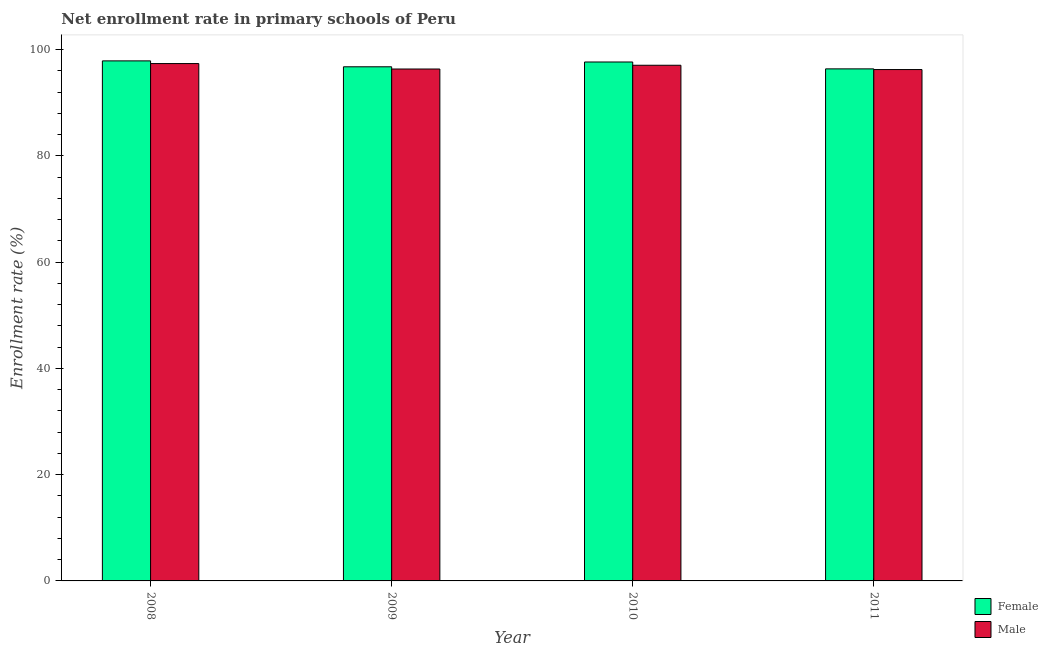Are the number of bars on each tick of the X-axis equal?
Ensure brevity in your answer.  Yes. How many bars are there on the 2nd tick from the left?
Offer a very short reply. 2. How many bars are there on the 1st tick from the right?
Provide a short and direct response. 2. In how many cases, is the number of bars for a given year not equal to the number of legend labels?
Your answer should be compact. 0. What is the enrollment rate of female students in 2009?
Your answer should be very brief. 96.78. Across all years, what is the maximum enrollment rate of male students?
Offer a very short reply. 97.39. Across all years, what is the minimum enrollment rate of female students?
Your answer should be very brief. 96.39. In which year was the enrollment rate of female students minimum?
Your answer should be very brief. 2011. What is the total enrollment rate of male students in the graph?
Your response must be concise. 387.09. What is the difference between the enrollment rate of female students in 2008 and that in 2011?
Your answer should be compact. 1.5. What is the difference between the enrollment rate of male students in 2008 and the enrollment rate of female students in 2010?
Offer a very short reply. 0.32. What is the average enrollment rate of female students per year?
Provide a short and direct response. 97.19. In the year 2009, what is the difference between the enrollment rate of male students and enrollment rate of female students?
Give a very brief answer. 0. What is the ratio of the enrollment rate of female students in 2008 to that in 2010?
Provide a short and direct response. 1. Is the difference between the enrollment rate of female students in 2010 and 2011 greater than the difference between the enrollment rate of male students in 2010 and 2011?
Keep it short and to the point. No. What is the difference between the highest and the second highest enrollment rate of female students?
Your answer should be compact. 0.21. What is the difference between the highest and the lowest enrollment rate of female students?
Offer a very short reply. 1.5. How many bars are there?
Your response must be concise. 8. Are all the bars in the graph horizontal?
Provide a short and direct response. No. Does the graph contain any zero values?
Provide a succinct answer. No. Where does the legend appear in the graph?
Keep it short and to the point. Bottom right. How many legend labels are there?
Give a very brief answer. 2. How are the legend labels stacked?
Provide a short and direct response. Vertical. What is the title of the graph?
Provide a succinct answer. Net enrollment rate in primary schools of Peru. What is the label or title of the X-axis?
Make the answer very short. Year. What is the label or title of the Y-axis?
Your answer should be very brief. Enrollment rate (%). What is the Enrollment rate (%) in Female in 2008?
Your answer should be very brief. 97.9. What is the Enrollment rate (%) in Male in 2008?
Your response must be concise. 97.39. What is the Enrollment rate (%) in Female in 2009?
Keep it short and to the point. 96.78. What is the Enrollment rate (%) of Male in 2009?
Offer a very short reply. 96.36. What is the Enrollment rate (%) of Female in 2010?
Provide a short and direct response. 97.69. What is the Enrollment rate (%) of Male in 2010?
Make the answer very short. 97.07. What is the Enrollment rate (%) in Female in 2011?
Your answer should be very brief. 96.39. What is the Enrollment rate (%) of Male in 2011?
Offer a very short reply. 96.26. Across all years, what is the maximum Enrollment rate (%) in Female?
Give a very brief answer. 97.9. Across all years, what is the maximum Enrollment rate (%) in Male?
Ensure brevity in your answer.  97.39. Across all years, what is the minimum Enrollment rate (%) of Female?
Offer a terse response. 96.39. Across all years, what is the minimum Enrollment rate (%) in Male?
Give a very brief answer. 96.26. What is the total Enrollment rate (%) of Female in the graph?
Your response must be concise. 388.76. What is the total Enrollment rate (%) in Male in the graph?
Offer a terse response. 387.09. What is the difference between the Enrollment rate (%) of Female in 2008 and that in 2009?
Offer a very short reply. 1.11. What is the difference between the Enrollment rate (%) in Male in 2008 and that in 2009?
Keep it short and to the point. 1.03. What is the difference between the Enrollment rate (%) in Female in 2008 and that in 2010?
Offer a terse response. 0.21. What is the difference between the Enrollment rate (%) in Male in 2008 and that in 2010?
Offer a terse response. 0.32. What is the difference between the Enrollment rate (%) of Female in 2008 and that in 2011?
Keep it short and to the point. 1.5. What is the difference between the Enrollment rate (%) of Male in 2008 and that in 2011?
Offer a terse response. 1.13. What is the difference between the Enrollment rate (%) of Female in 2009 and that in 2010?
Offer a terse response. -0.9. What is the difference between the Enrollment rate (%) in Male in 2009 and that in 2010?
Your response must be concise. -0.71. What is the difference between the Enrollment rate (%) of Female in 2009 and that in 2011?
Offer a terse response. 0.39. What is the difference between the Enrollment rate (%) of Male in 2009 and that in 2011?
Give a very brief answer. 0.1. What is the difference between the Enrollment rate (%) in Female in 2010 and that in 2011?
Make the answer very short. 1.29. What is the difference between the Enrollment rate (%) in Male in 2010 and that in 2011?
Keep it short and to the point. 0.81. What is the difference between the Enrollment rate (%) in Female in 2008 and the Enrollment rate (%) in Male in 2009?
Your response must be concise. 1.53. What is the difference between the Enrollment rate (%) of Female in 2008 and the Enrollment rate (%) of Male in 2010?
Give a very brief answer. 0.82. What is the difference between the Enrollment rate (%) in Female in 2008 and the Enrollment rate (%) in Male in 2011?
Provide a short and direct response. 1.63. What is the difference between the Enrollment rate (%) in Female in 2009 and the Enrollment rate (%) in Male in 2010?
Give a very brief answer. -0.29. What is the difference between the Enrollment rate (%) of Female in 2009 and the Enrollment rate (%) of Male in 2011?
Your response must be concise. 0.52. What is the difference between the Enrollment rate (%) of Female in 2010 and the Enrollment rate (%) of Male in 2011?
Provide a short and direct response. 1.42. What is the average Enrollment rate (%) of Female per year?
Offer a very short reply. 97.19. What is the average Enrollment rate (%) in Male per year?
Give a very brief answer. 96.77. In the year 2008, what is the difference between the Enrollment rate (%) in Female and Enrollment rate (%) in Male?
Your answer should be very brief. 0.51. In the year 2009, what is the difference between the Enrollment rate (%) in Female and Enrollment rate (%) in Male?
Keep it short and to the point. 0.42. In the year 2010, what is the difference between the Enrollment rate (%) in Female and Enrollment rate (%) in Male?
Your answer should be compact. 0.61. In the year 2011, what is the difference between the Enrollment rate (%) in Female and Enrollment rate (%) in Male?
Provide a short and direct response. 0.13. What is the ratio of the Enrollment rate (%) of Female in 2008 to that in 2009?
Ensure brevity in your answer.  1.01. What is the ratio of the Enrollment rate (%) of Male in 2008 to that in 2009?
Your answer should be very brief. 1.01. What is the ratio of the Enrollment rate (%) in Male in 2008 to that in 2010?
Your answer should be compact. 1. What is the ratio of the Enrollment rate (%) in Female in 2008 to that in 2011?
Keep it short and to the point. 1.02. What is the ratio of the Enrollment rate (%) in Male in 2008 to that in 2011?
Keep it short and to the point. 1.01. What is the ratio of the Enrollment rate (%) in Female in 2009 to that in 2010?
Offer a terse response. 0.99. What is the ratio of the Enrollment rate (%) of Male in 2009 to that in 2010?
Your response must be concise. 0.99. What is the ratio of the Enrollment rate (%) of Female in 2009 to that in 2011?
Your answer should be compact. 1. What is the ratio of the Enrollment rate (%) of Female in 2010 to that in 2011?
Your answer should be compact. 1.01. What is the ratio of the Enrollment rate (%) in Male in 2010 to that in 2011?
Offer a very short reply. 1.01. What is the difference between the highest and the second highest Enrollment rate (%) in Female?
Offer a terse response. 0.21. What is the difference between the highest and the second highest Enrollment rate (%) in Male?
Your answer should be compact. 0.32. What is the difference between the highest and the lowest Enrollment rate (%) of Female?
Provide a short and direct response. 1.5. What is the difference between the highest and the lowest Enrollment rate (%) of Male?
Provide a short and direct response. 1.13. 